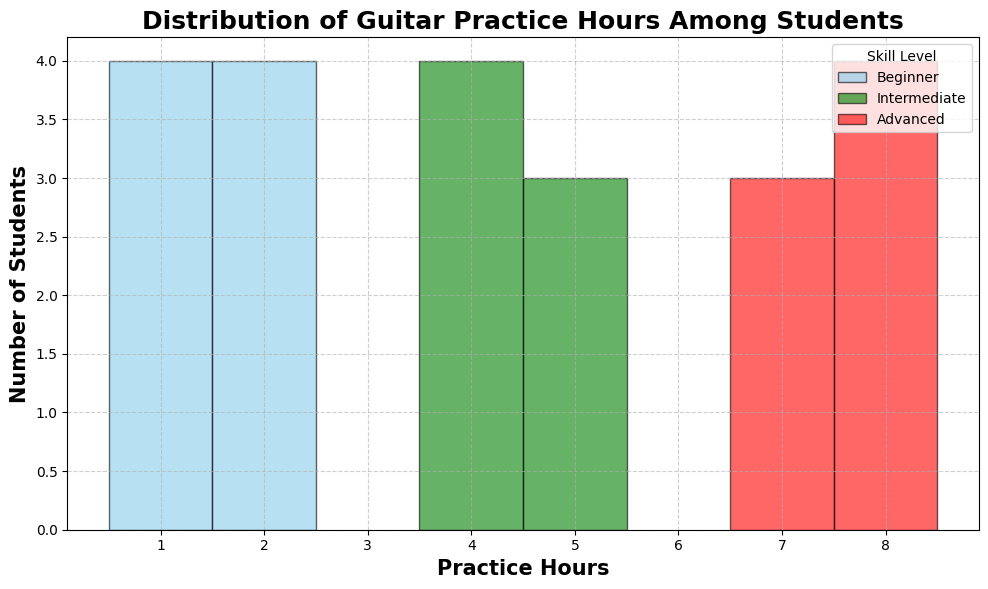What is the most common practice hour range for Beginner students? Beginner students' bars peak at 2 hours. By counting the height of each bar, we can see that the most common practice hours among Beginner students are 2 hours.
Answer: 2 hours Among Intermediate students, how frequently do students practice for 6 hours? The height of the bar corresponding to "6 hours" for Intermediate students will tell us the number of students practicing for that duration. There are 4 students practicing for 6 hours among Intermediate students.
Answer: 4 Which skill level shows the widest range of practice hours? The Advanced skill level has bars ranging from 7 to 9 hours, which is a range of 3 hours. The Intermediate level has bars ranging from 4 to 6 hours, also a range of 3 hours. The Beginner level has bars from 1 to 3 hours, a range of 2 hours. Therefore, both Advanced and Intermediate have the same widest range of practice hours, which is 3 hours.
Answer: Advanced and Intermediate How many students practice for exactly 7 hours? Analyzing the bars corresponding to "7 hours," only Advanced students practice for 7 hours. The height of the bar indicates there are 3 students practicing for 7 hours.
Answer: 3 Which skill level has the highest number of total practice hours? To find the skill level with the highest total practice hours, sum up the practice hours for each student in each skill level:
- Beginners: \(1+2+1+3+2+1+2+3+2+1 = 18\)
- Intermediate: \(4+5+4+6+5+4+6+5+4+6 = 49\)
- Advanced: \(7+8+9+8+7+8+9+7+8+9 = 70\)
Thus, the Advanced skill level has the highest number of total practice hours.
Answer: Advanced Is the practice distribution uniform across all skill levels? By visually analyzing the histogram, we see that the practice hours for each skill level cluster around specific hours:
- Beginners: Around 1-3 hours
- Intermediate: Around 4-6 hours
- Advanced: Mostly 7 and 9 hours with some 8 hours
The distributions are not uniform and show clear clustering around specific practice hour ranges for each skill level.
Answer: No Between Intermediate and Advanced students, who has more students practicing for 5 hours? Check the bar corresponding to "5 hours" in the Intermediate and Advanced categories. There are 3 Intermediate students practicing for 5 hours compared to 0 from the Advanced category.
Answer: Intermediate How many more students practice for 8 hours in the Advanced level compared to the Intermediate level? There are 4 students practicing for 8 hours at the Advanced level and none at the Intermediate level. Therefore, the number of additional Advanced students is 4.
Answer: 4 What is the total number of students practicing for 2 hours across all skill levels? Summing up the bars for "2 hours" across skill levels (only Beginners in this case), there are 4 Beginner students practicing for 2 hours and no students from Intermediate or Advanced levels practicing for 2 hours.
Answer: 4 